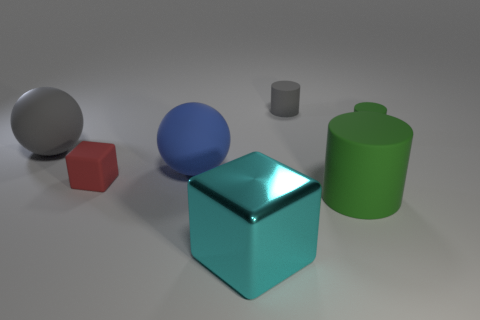Add 2 brown rubber spheres. How many objects exist? 9 Subtract all cylinders. How many objects are left? 4 Subtract 0 cyan cylinders. How many objects are left? 7 Subtract all large gray matte blocks. Subtract all large cyan metallic blocks. How many objects are left? 6 Add 3 red rubber things. How many red rubber things are left? 4 Add 6 big blue shiny cylinders. How many big blue shiny cylinders exist? 6 